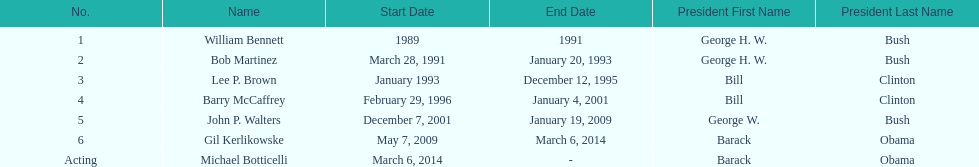Who serves inder barack obama? Gil Kerlikowske. 